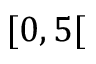Convert formula to latex. <formula><loc_0><loc_0><loc_500><loc_500>[ 0 , 5 [</formula> 